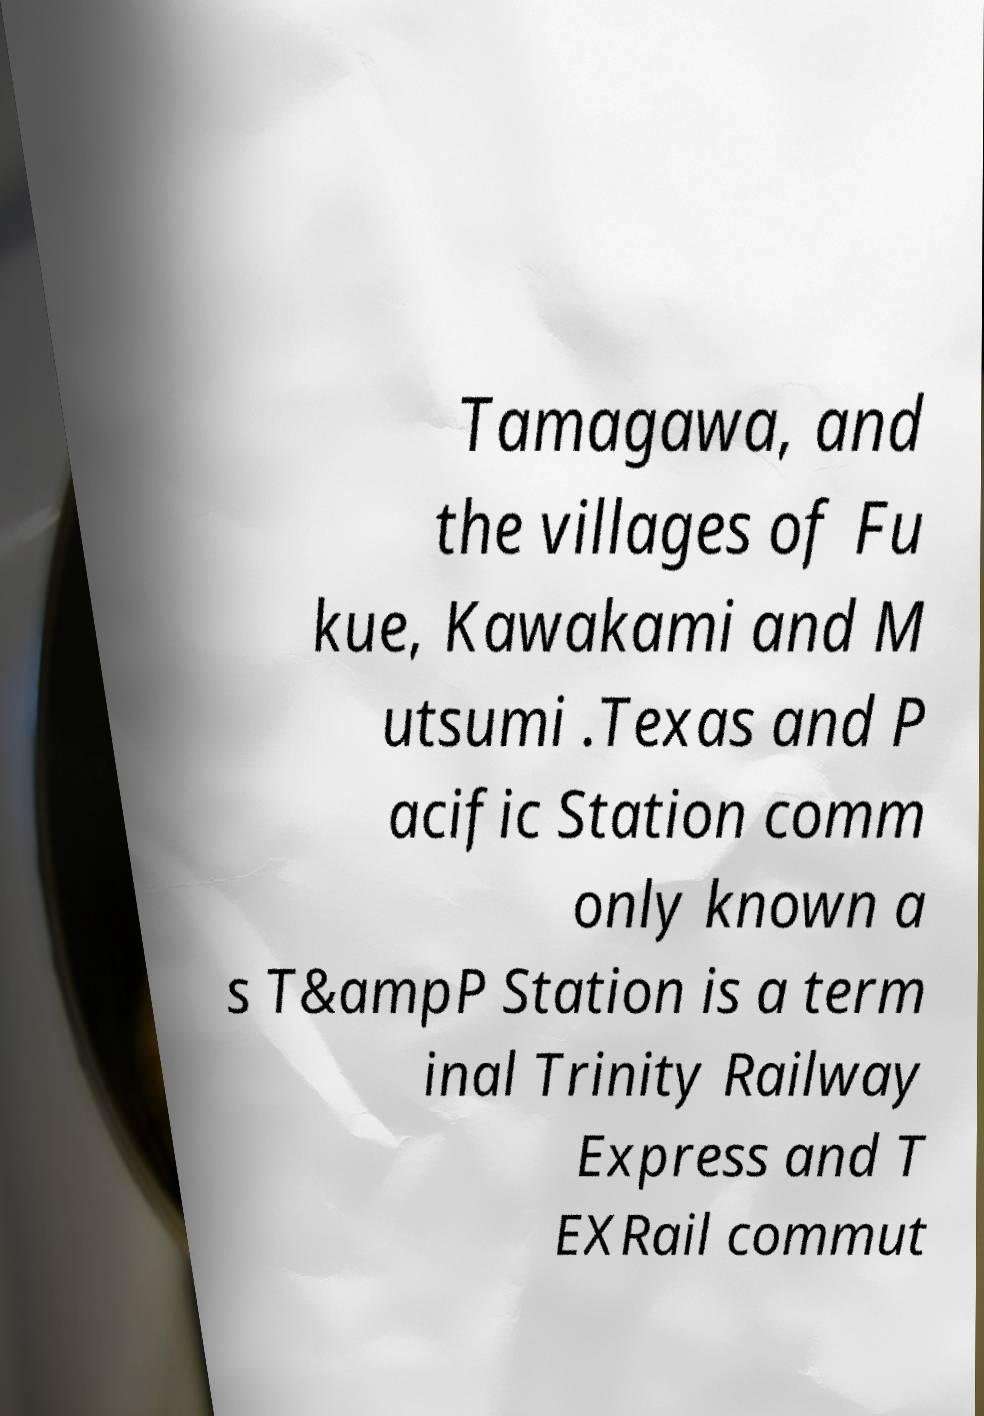Could you assist in decoding the text presented in this image and type it out clearly? Tamagawa, and the villages of Fu kue, Kawakami and M utsumi .Texas and P acific Station comm only known a s T&ampP Station is a term inal Trinity Railway Express and T EXRail commut 